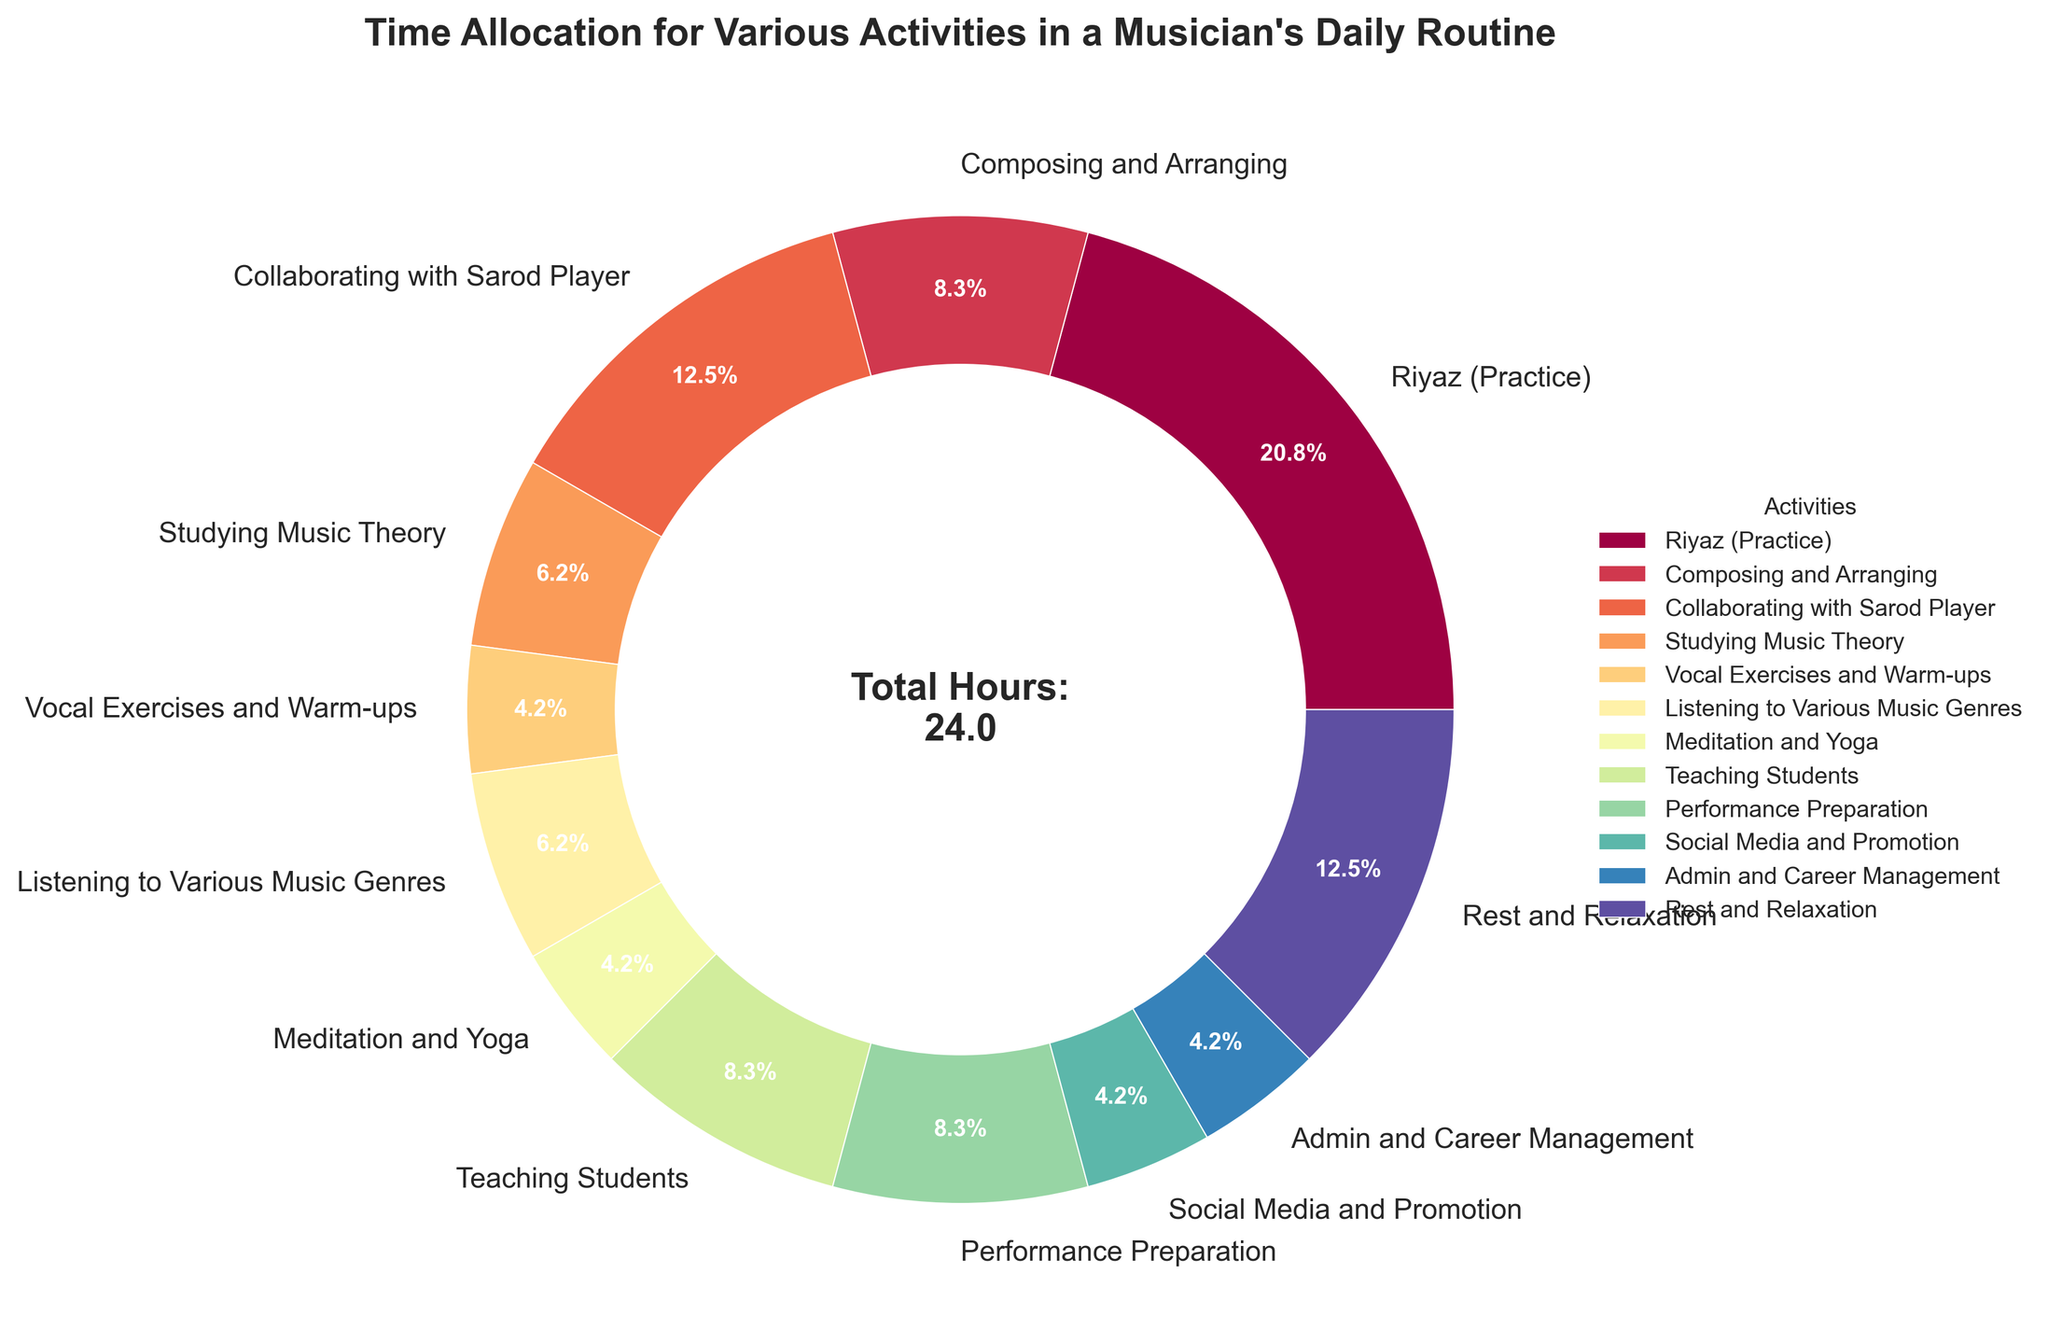What activity takes up the most time in a musician's daily routine? The largest segment in the pie chart is labeled as "Riyaz (Practice)" with 5 hours allocated.
Answer: Riyaz (Practice) What is the combined time spent on studying music theory and listening to various music genres? Studying Music Theory is 1.5 hours and Listening to Various Music Genres is also 1.5 hours. Combined, they total 1.5 + 1.5 = 3 hours.
Answer: 3 hours How does the time spent on collaborating with the sarod player compare with the time spent on teaching students? Collaborating with Sarod Player is 3 hours, while Teaching Students is 2 hours. Therefore, more time is spent on collaborating with the sarod player.
Answer: More time on collaborating with the sarod player By how many hours does practice time exceed performance preparation time? Riyaz (Practice) is 5 hours, and Performance Preparation is 2 hours. The difference is 5 - 2 = 3 hours.
Answer: 3 hours What proportion of the day is spent on rest and relaxation activities? Rest and Relaxation is 3 hours out of a total of 24 hours, shown on the pie chart as 12.5%.
Answer: 12.5% Which activity is allocated exactly 1 hour, and what color is it represented by? The activity allocated exactly 1 hour is "Vocal Exercises and Warm-ups." It is represented by a specific segment color in the pie chart.
Answer: Vocal Exercises and Warm-ups How many activities take up more than 2 hours each? From the pie chart, only Riyaz (Practice) with 5 hours and Rest and Relaxation with 3 hours exceed 2 hours.
Answer: 2 activities Calculate the difference in hours between the time spent on social media and promotion versus admin and career management. Both "Social Media and Promotion" and "Admin and Career Management" are allocated 1 hour each. Therefore, the difference is 1 - 1 = 0 hours.
Answer: 0 hours What fraction of time is spent on teaching students relative to the total number of hours? Teaching Students is allocated 2 hours out of a total of 24 hours. This makes the fraction 2/24, which simplifies to 1/12.
Answer: 1/12 How much more time is spent on practice compared to meditation and yoga combined? Riyaz (Practice) is 5 hours, and Meditation and Yoga is 1 hour. The difference is 5 - 1 = 4 hours.
Answer: 4 hours 